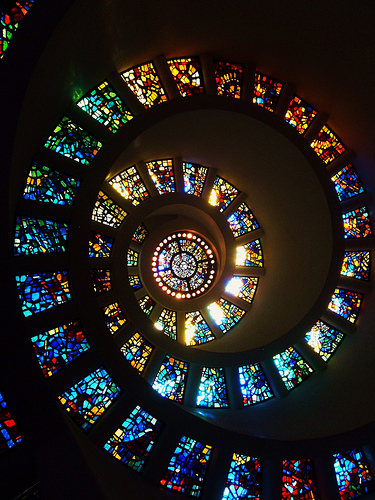<image>
Can you confirm if the window is next to the window? Yes. The window is positioned adjacent to the window, located nearby in the same general area. 